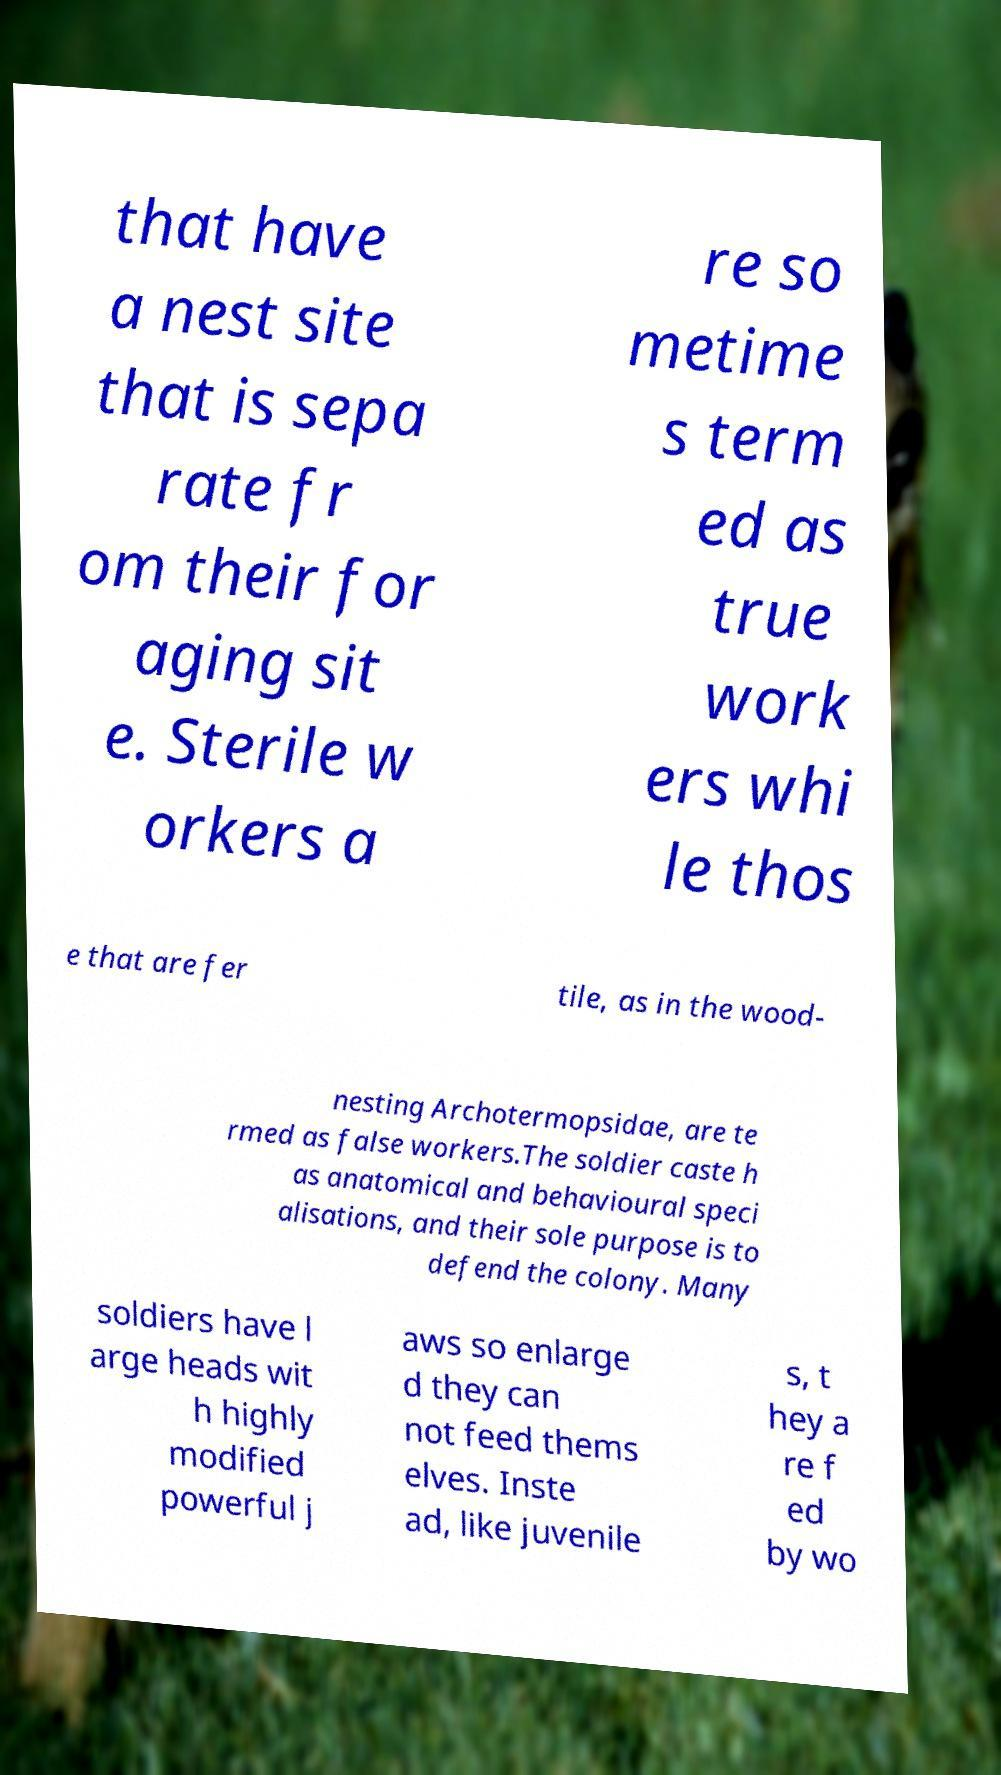Could you assist in decoding the text presented in this image and type it out clearly? that have a nest site that is sepa rate fr om their for aging sit e. Sterile w orkers a re so metime s term ed as true work ers whi le thos e that are fer tile, as in the wood- nesting Archotermopsidae, are te rmed as false workers.The soldier caste h as anatomical and behavioural speci alisations, and their sole purpose is to defend the colony. Many soldiers have l arge heads wit h highly modified powerful j aws so enlarge d they can not feed thems elves. Inste ad, like juvenile s, t hey a re f ed by wo 